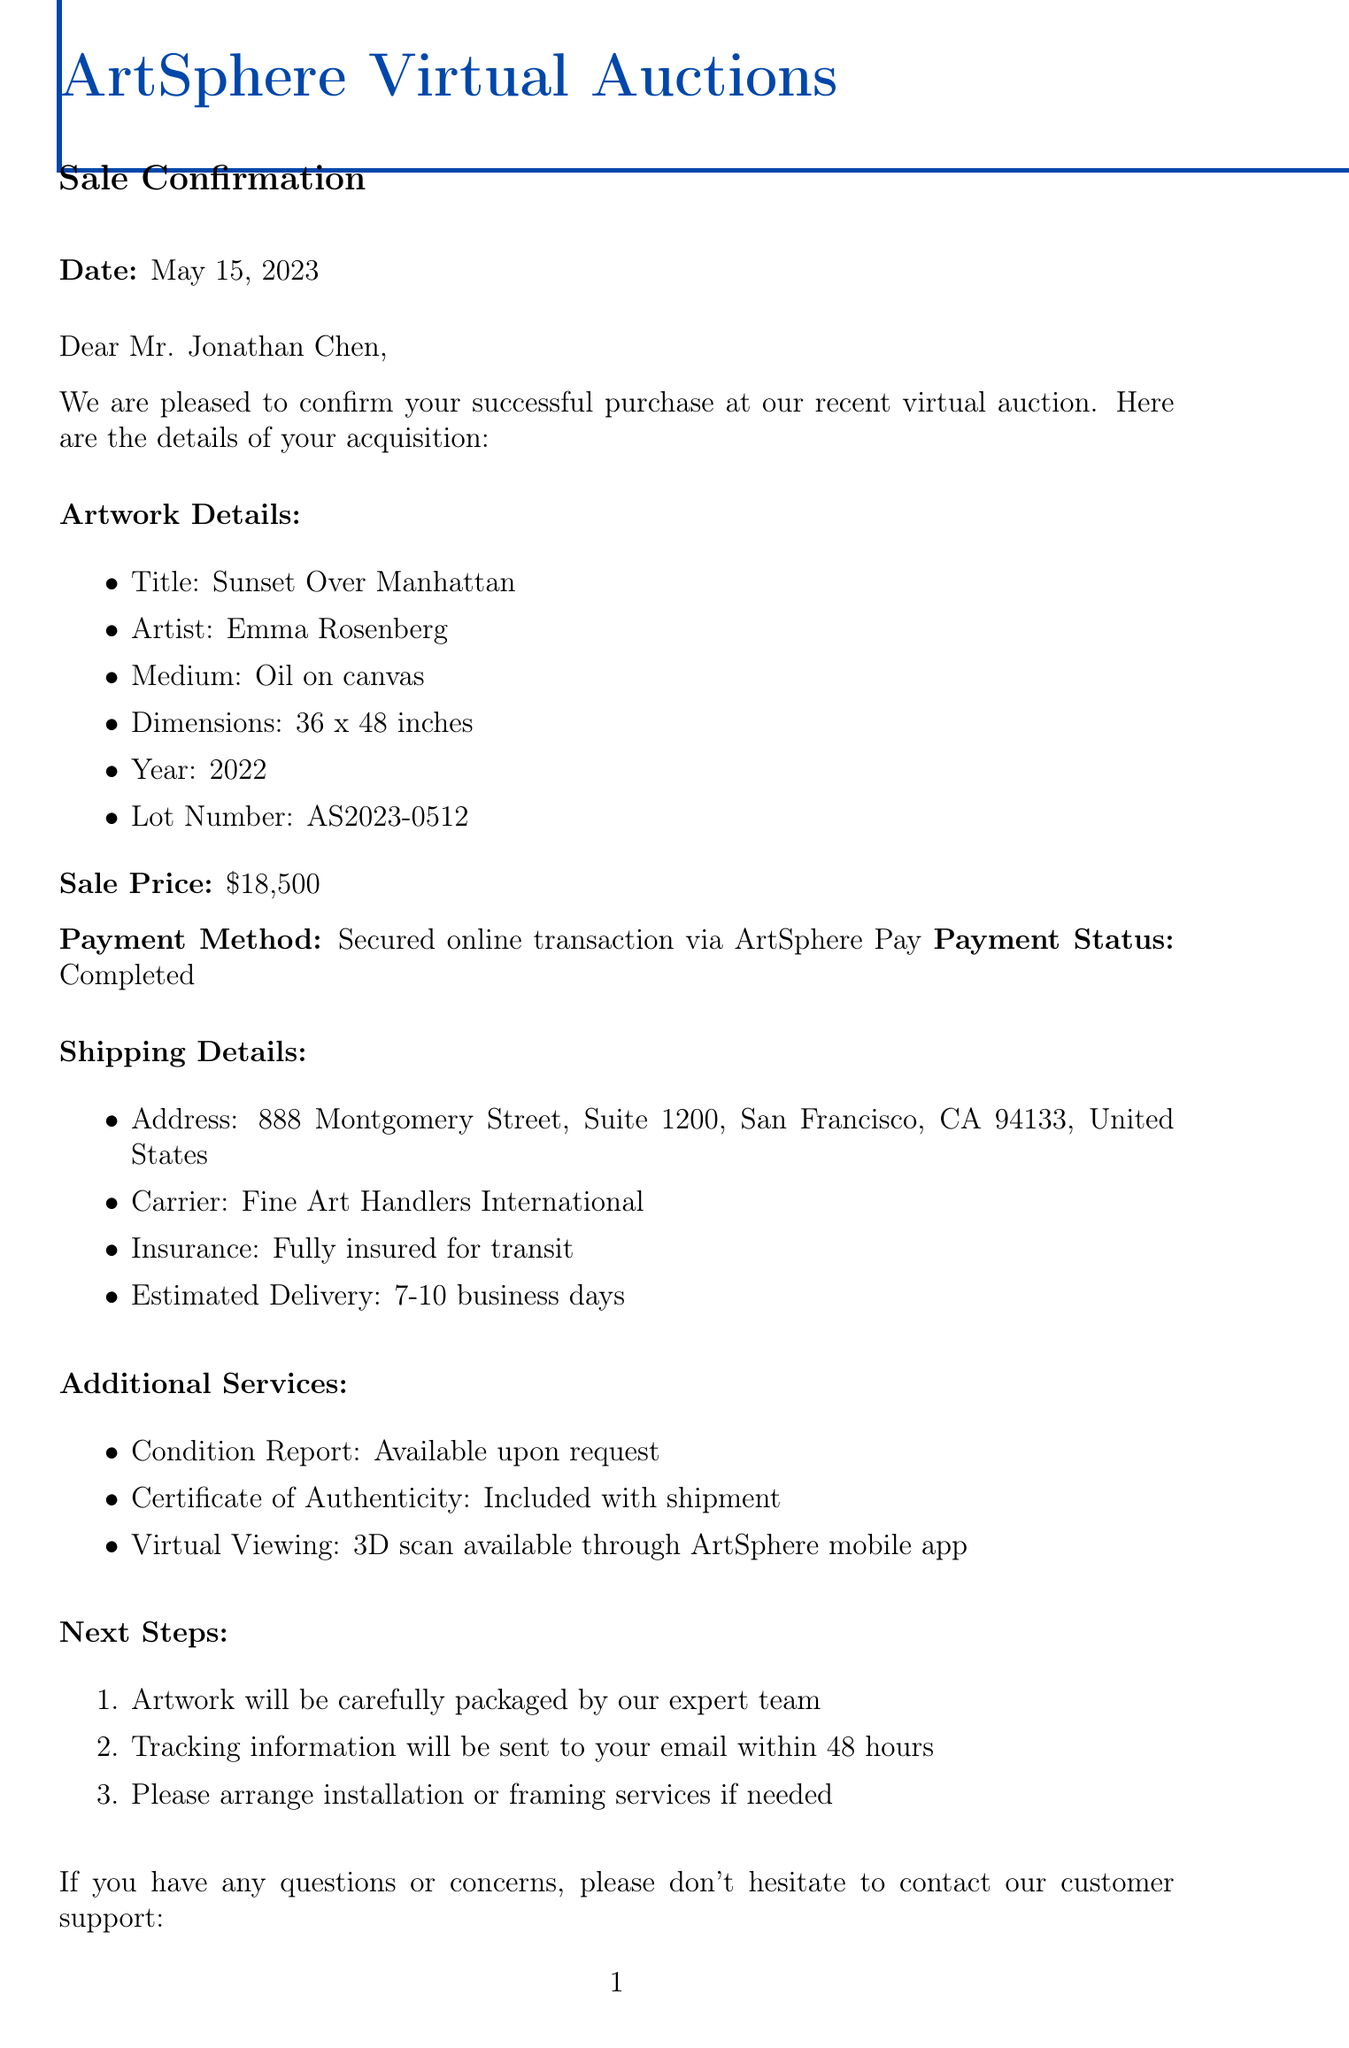What is the title of the artwork? The title of the artwork is specified under Artwork Details in the document.
Answer: Sunset Over Manhattan Who is the artist of the purchased artwork? The artist's name is mentioned in the Artwork Details section of the document.
Answer: Emma Rosenberg What is the sale price of the artwork? The sale price is clearly indicated in the document next to Sale Price.
Answer: $18,500 What is the estimated delivery time for the artwork? The estimated delivery time is outlined in the Shipping Details section.
Answer: 7-10 business days What is the buyer's email address? The buyer's email address is provided in the Buyer Information section of the document.
Answer: jonathan.chen@chenartinvestments.com What commission percentage does the seller receive? The seller commission is mentioned towards the end of the document.
Answer: 15% How will the buyer receive tracking information? The method of receiving tracking information is detailed in the Next Steps section.
Answer: Email within 48 hours What additional service is included with the shipment? This service is mentioned under Additional Services in the document.
Answer: Certificate of Authenticity What is the next auction event? The next event is specified in the Upcoming Auctions section.
Answer: Contemporary Asian Art 